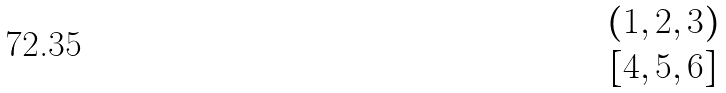Convert formula to latex. <formula><loc_0><loc_0><loc_500><loc_500>\begin{matrix} { \text {$(1,2,3)$} } \\ { \text {$[4,5,6]$} } \end{matrix}</formula> 